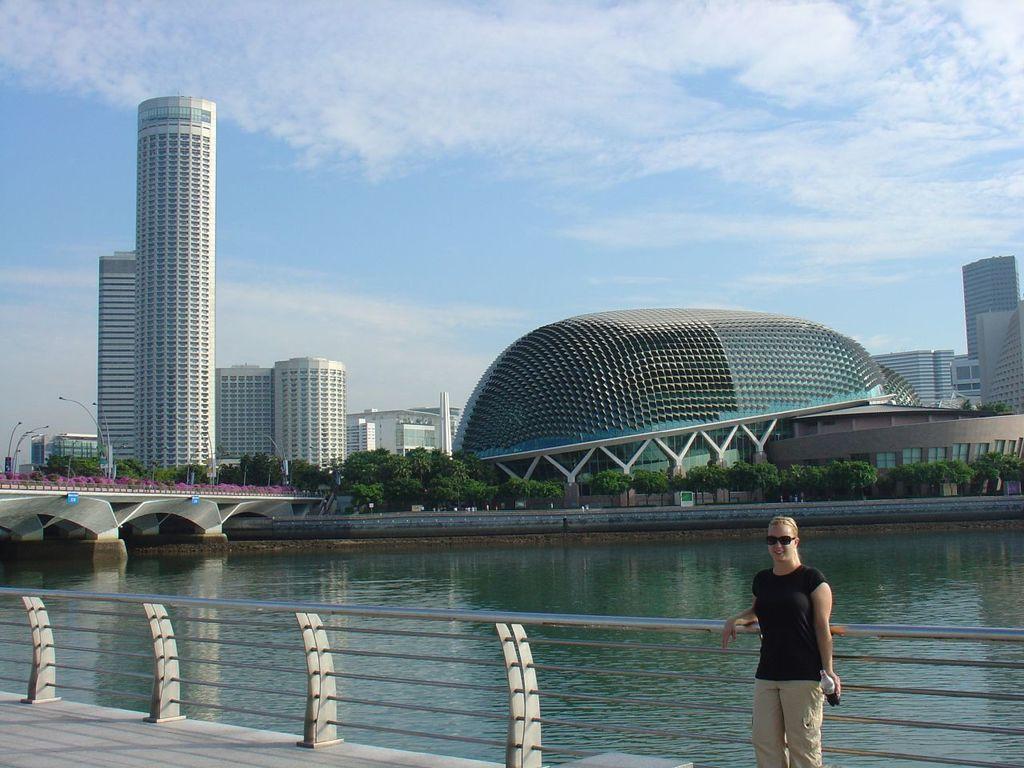Describe this image in one or two sentences. In this image we can see a person wearing goggles. And the person is holding a bottle. Near to the person there is a railing. Also there is water. On the left side there is a bridge. In the background there are trees, buildings, light poles and sky with clouds. 